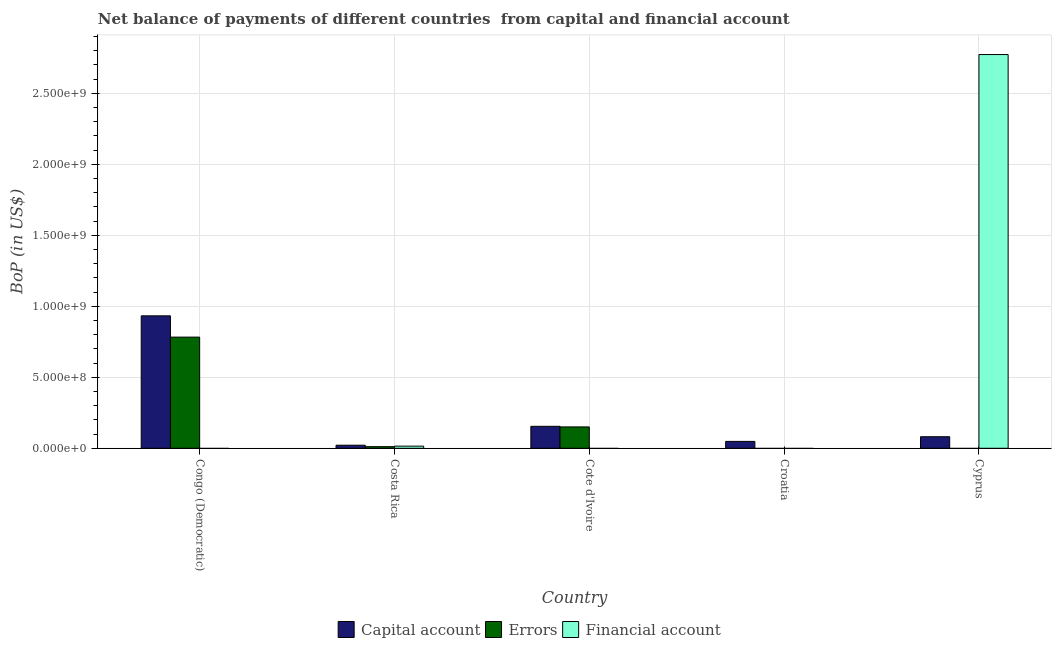How many different coloured bars are there?
Your answer should be compact. 3. Are the number of bars per tick equal to the number of legend labels?
Offer a very short reply. No. What is the label of the 1st group of bars from the left?
Your answer should be compact. Congo (Democratic). What is the amount of financial account in Congo (Democratic)?
Ensure brevity in your answer.  0. Across all countries, what is the maximum amount of net capital account?
Offer a very short reply. 9.33e+08. In which country was the amount of net capital account maximum?
Your response must be concise. Congo (Democratic). What is the total amount of net capital account in the graph?
Provide a succinct answer. 1.24e+09. What is the difference between the amount of net capital account in Costa Rica and that in Croatia?
Your response must be concise. -2.69e+07. What is the difference between the amount of financial account in Costa Rica and the amount of errors in Cyprus?
Make the answer very short. 1.52e+07. What is the average amount of financial account per country?
Your answer should be compact. 5.58e+08. What is the difference between the amount of financial account and amount of net capital account in Costa Rica?
Offer a terse response. -6.43e+06. In how many countries, is the amount of errors greater than 500000000 US$?
Offer a very short reply. 1. What is the ratio of the amount of net capital account in Congo (Democratic) to that in Costa Rica?
Your response must be concise. 43.17. Is the amount of errors in Congo (Democratic) less than that in Costa Rica?
Make the answer very short. No. What is the difference between the highest and the second highest amount of net capital account?
Your response must be concise. 7.78e+08. What is the difference between the highest and the lowest amount of net capital account?
Ensure brevity in your answer.  9.11e+08. Is the sum of the amount of net capital account in Croatia and Cyprus greater than the maximum amount of errors across all countries?
Keep it short and to the point. No. Is it the case that in every country, the sum of the amount of net capital account and amount of errors is greater than the amount of financial account?
Provide a succinct answer. No. How many bars are there?
Your response must be concise. 10. Are all the bars in the graph horizontal?
Your answer should be very brief. No. What is the difference between two consecutive major ticks on the Y-axis?
Provide a succinct answer. 5.00e+08. Does the graph contain grids?
Keep it short and to the point. Yes. How many legend labels are there?
Provide a succinct answer. 3. How are the legend labels stacked?
Provide a short and direct response. Horizontal. What is the title of the graph?
Ensure brevity in your answer.  Net balance of payments of different countries  from capital and financial account. What is the label or title of the Y-axis?
Provide a short and direct response. BoP (in US$). What is the BoP (in US$) of Capital account in Congo (Democratic)?
Keep it short and to the point. 9.33e+08. What is the BoP (in US$) in Errors in Congo (Democratic)?
Keep it short and to the point. 7.83e+08. What is the BoP (in US$) of Financial account in Congo (Democratic)?
Offer a very short reply. 0. What is the BoP (in US$) in Capital account in Costa Rica?
Offer a terse response. 2.16e+07. What is the BoP (in US$) of Errors in Costa Rica?
Offer a very short reply. 1.13e+07. What is the BoP (in US$) in Financial account in Costa Rica?
Provide a short and direct response. 1.52e+07. What is the BoP (in US$) of Capital account in Cote d'Ivoire?
Provide a succinct answer. 1.55e+08. What is the BoP (in US$) of Errors in Cote d'Ivoire?
Your answer should be very brief. 1.50e+08. What is the BoP (in US$) of Financial account in Cote d'Ivoire?
Offer a very short reply. 0. What is the BoP (in US$) in Capital account in Croatia?
Provide a short and direct response. 4.85e+07. What is the BoP (in US$) of Financial account in Croatia?
Your answer should be very brief. 0. What is the BoP (in US$) in Capital account in Cyprus?
Offer a terse response. 8.13e+07. What is the BoP (in US$) in Financial account in Cyprus?
Your answer should be very brief. 2.77e+09. Across all countries, what is the maximum BoP (in US$) of Capital account?
Provide a short and direct response. 9.33e+08. Across all countries, what is the maximum BoP (in US$) in Errors?
Your answer should be very brief. 7.83e+08. Across all countries, what is the maximum BoP (in US$) in Financial account?
Ensure brevity in your answer.  2.77e+09. Across all countries, what is the minimum BoP (in US$) of Capital account?
Your answer should be very brief. 2.16e+07. Across all countries, what is the minimum BoP (in US$) in Errors?
Give a very brief answer. 0. What is the total BoP (in US$) in Capital account in the graph?
Provide a short and direct response. 1.24e+09. What is the total BoP (in US$) in Errors in the graph?
Offer a very short reply. 9.45e+08. What is the total BoP (in US$) in Financial account in the graph?
Your answer should be very brief. 2.79e+09. What is the difference between the BoP (in US$) in Capital account in Congo (Democratic) and that in Costa Rica?
Provide a succinct answer. 9.11e+08. What is the difference between the BoP (in US$) in Errors in Congo (Democratic) and that in Costa Rica?
Offer a terse response. 7.72e+08. What is the difference between the BoP (in US$) in Capital account in Congo (Democratic) and that in Cote d'Ivoire?
Provide a succinct answer. 7.78e+08. What is the difference between the BoP (in US$) in Errors in Congo (Democratic) and that in Cote d'Ivoire?
Ensure brevity in your answer.  6.32e+08. What is the difference between the BoP (in US$) of Capital account in Congo (Democratic) and that in Croatia?
Your answer should be very brief. 8.84e+08. What is the difference between the BoP (in US$) of Capital account in Congo (Democratic) and that in Cyprus?
Make the answer very short. 8.51e+08. What is the difference between the BoP (in US$) in Capital account in Costa Rica and that in Cote d'Ivoire?
Keep it short and to the point. -1.33e+08. What is the difference between the BoP (in US$) of Errors in Costa Rica and that in Cote d'Ivoire?
Give a very brief answer. -1.39e+08. What is the difference between the BoP (in US$) in Capital account in Costa Rica and that in Croatia?
Your answer should be compact. -2.69e+07. What is the difference between the BoP (in US$) of Capital account in Costa Rica and that in Cyprus?
Provide a succinct answer. -5.97e+07. What is the difference between the BoP (in US$) of Financial account in Costa Rica and that in Cyprus?
Make the answer very short. -2.76e+09. What is the difference between the BoP (in US$) in Capital account in Cote d'Ivoire and that in Croatia?
Your response must be concise. 1.06e+08. What is the difference between the BoP (in US$) of Capital account in Cote d'Ivoire and that in Cyprus?
Ensure brevity in your answer.  7.33e+07. What is the difference between the BoP (in US$) of Capital account in Croatia and that in Cyprus?
Make the answer very short. -3.28e+07. What is the difference between the BoP (in US$) of Capital account in Congo (Democratic) and the BoP (in US$) of Errors in Costa Rica?
Your answer should be compact. 9.21e+08. What is the difference between the BoP (in US$) in Capital account in Congo (Democratic) and the BoP (in US$) in Financial account in Costa Rica?
Provide a succinct answer. 9.18e+08. What is the difference between the BoP (in US$) in Errors in Congo (Democratic) and the BoP (in US$) in Financial account in Costa Rica?
Ensure brevity in your answer.  7.68e+08. What is the difference between the BoP (in US$) in Capital account in Congo (Democratic) and the BoP (in US$) in Errors in Cote d'Ivoire?
Your answer should be compact. 7.82e+08. What is the difference between the BoP (in US$) of Capital account in Congo (Democratic) and the BoP (in US$) of Financial account in Cyprus?
Provide a short and direct response. -1.84e+09. What is the difference between the BoP (in US$) in Errors in Congo (Democratic) and the BoP (in US$) in Financial account in Cyprus?
Give a very brief answer. -1.99e+09. What is the difference between the BoP (in US$) in Capital account in Costa Rica and the BoP (in US$) in Errors in Cote d'Ivoire?
Provide a short and direct response. -1.29e+08. What is the difference between the BoP (in US$) of Capital account in Costa Rica and the BoP (in US$) of Financial account in Cyprus?
Give a very brief answer. -2.75e+09. What is the difference between the BoP (in US$) in Errors in Costa Rica and the BoP (in US$) in Financial account in Cyprus?
Keep it short and to the point. -2.76e+09. What is the difference between the BoP (in US$) of Capital account in Cote d'Ivoire and the BoP (in US$) of Financial account in Cyprus?
Your answer should be very brief. -2.62e+09. What is the difference between the BoP (in US$) in Errors in Cote d'Ivoire and the BoP (in US$) in Financial account in Cyprus?
Your answer should be very brief. -2.62e+09. What is the difference between the BoP (in US$) of Capital account in Croatia and the BoP (in US$) of Financial account in Cyprus?
Keep it short and to the point. -2.72e+09. What is the average BoP (in US$) in Capital account per country?
Provide a short and direct response. 2.48e+08. What is the average BoP (in US$) in Errors per country?
Your response must be concise. 1.89e+08. What is the average BoP (in US$) in Financial account per country?
Your answer should be very brief. 5.58e+08. What is the difference between the BoP (in US$) in Capital account and BoP (in US$) in Errors in Congo (Democratic)?
Give a very brief answer. 1.50e+08. What is the difference between the BoP (in US$) in Capital account and BoP (in US$) in Errors in Costa Rica?
Make the answer very short. 1.03e+07. What is the difference between the BoP (in US$) in Capital account and BoP (in US$) in Financial account in Costa Rica?
Offer a terse response. 6.43e+06. What is the difference between the BoP (in US$) in Errors and BoP (in US$) in Financial account in Costa Rica?
Offer a very short reply. -3.83e+06. What is the difference between the BoP (in US$) of Capital account and BoP (in US$) of Errors in Cote d'Ivoire?
Provide a succinct answer. 4.16e+06. What is the difference between the BoP (in US$) in Capital account and BoP (in US$) in Financial account in Cyprus?
Keep it short and to the point. -2.69e+09. What is the ratio of the BoP (in US$) in Capital account in Congo (Democratic) to that in Costa Rica?
Your response must be concise. 43.17. What is the ratio of the BoP (in US$) in Errors in Congo (Democratic) to that in Costa Rica?
Provide a succinct answer. 69.01. What is the ratio of the BoP (in US$) in Capital account in Congo (Democratic) to that in Cote d'Ivoire?
Your answer should be very brief. 6.03. What is the ratio of the BoP (in US$) of Errors in Congo (Democratic) to that in Cote d'Ivoire?
Your response must be concise. 5.2. What is the ratio of the BoP (in US$) in Capital account in Congo (Democratic) to that in Croatia?
Offer a terse response. 19.22. What is the ratio of the BoP (in US$) of Capital account in Congo (Democratic) to that in Cyprus?
Your answer should be very brief. 11.47. What is the ratio of the BoP (in US$) in Capital account in Costa Rica to that in Cote d'Ivoire?
Your response must be concise. 0.14. What is the ratio of the BoP (in US$) of Errors in Costa Rica to that in Cote d'Ivoire?
Offer a very short reply. 0.08. What is the ratio of the BoP (in US$) in Capital account in Costa Rica to that in Croatia?
Give a very brief answer. 0.45. What is the ratio of the BoP (in US$) in Capital account in Costa Rica to that in Cyprus?
Offer a very short reply. 0.27. What is the ratio of the BoP (in US$) of Financial account in Costa Rica to that in Cyprus?
Make the answer very short. 0.01. What is the ratio of the BoP (in US$) in Capital account in Cote d'Ivoire to that in Croatia?
Provide a short and direct response. 3.19. What is the ratio of the BoP (in US$) of Capital account in Cote d'Ivoire to that in Cyprus?
Offer a very short reply. 1.9. What is the ratio of the BoP (in US$) of Capital account in Croatia to that in Cyprus?
Offer a terse response. 0.6. What is the difference between the highest and the second highest BoP (in US$) of Capital account?
Ensure brevity in your answer.  7.78e+08. What is the difference between the highest and the second highest BoP (in US$) of Errors?
Your response must be concise. 6.32e+08. What is the difference between the highest and the lowest BoP (in US$) of Capital account?
Give a very brief answer. 9.11e+08. What is the difference between the highest and the lowest BoP (in US$) of Errors?
Offer a terse response. 7.83e+08. What is the difference between the highest and the lowest BoP (in US$) of Financial account?
Your answer should be compact. 2.77e+09. 